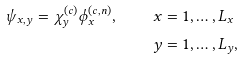<formula> <loc_0><loc_0><loc_500><loc_500>\psi _ { x , y } = \chi ^ { ( c ) } _ { y } \phi ^ { ( c , n ) } _ { x } , \quad x & = 1 , \dots , L _ { x } \\ y & = 1 , \dots , L _ { y } ,</formula> 